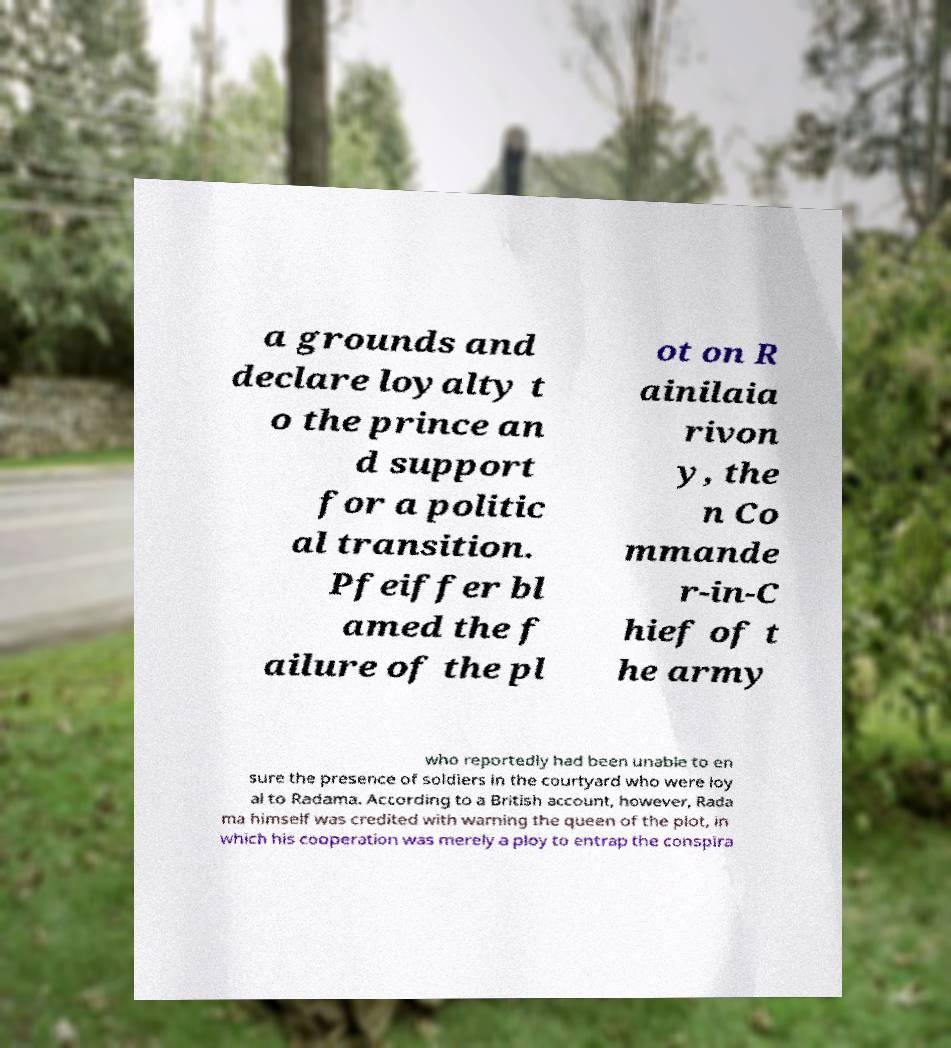Please identify and transcribe the text found in this image. a grounds and declare loyalty t o the prince an d support for a politic al transition. Pfeiffer bl amed the f ailure of the pl ot on R ainilaia rivon y, the n Co mmande r-in-C hief of t he army who reportedly had been unable to en sure the presence of soldiers in the courtyard who were loy al to Radama. According to a British account, however, Rada ma himself was credited with warning the queen of the plot, in which his cooperation was merely a ploy to entrap the conspira 